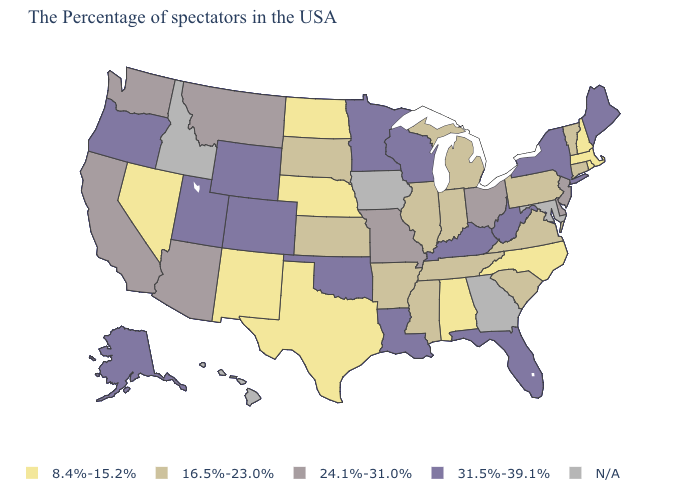Among the states that border North Dakota , does Minnesota have the lowest value?
Give a very brief answer. No. Among the states that border Iowa , does Nebraska have the lowest value?
Short answer required. Yes. Is the legend a continuous bar?
Short answer required. No. What is the value of Colorado?
Concise answer only. 31.5%-39.1%. Among the states that border Washington , which have the highest value?
Be succinct. Oregon. Does Wisconsin have the highest value in the MidWest?
Write a very short answer. Yes. Which states have the lowest value in the Northeast?
Give a very brief answer. Massachusetts, Rhode Island, New Hampshire. Does Kentucky have the highest value in the USA?
Keep it brief. Yes. What is the value of West Virginia?
Answer briefly. 31.5%-39.1%. Among the states that border West Virginia , which have the highest value?
Be succinct. Kentucky. Among the states that border Iowa , which have the lowest value?
Concise answer only. Nebraska. Does the map have missing data?
Short answer required. Yes. Name the states that have a value in the range 24.1%-31.0%?
Concise answer only. New Jersey, Delaware, Ohio, Missouri, Montana, Arizona, California, Washington. What is the value of Tennessee?
Be succinct. 16.5%-23.0%. 